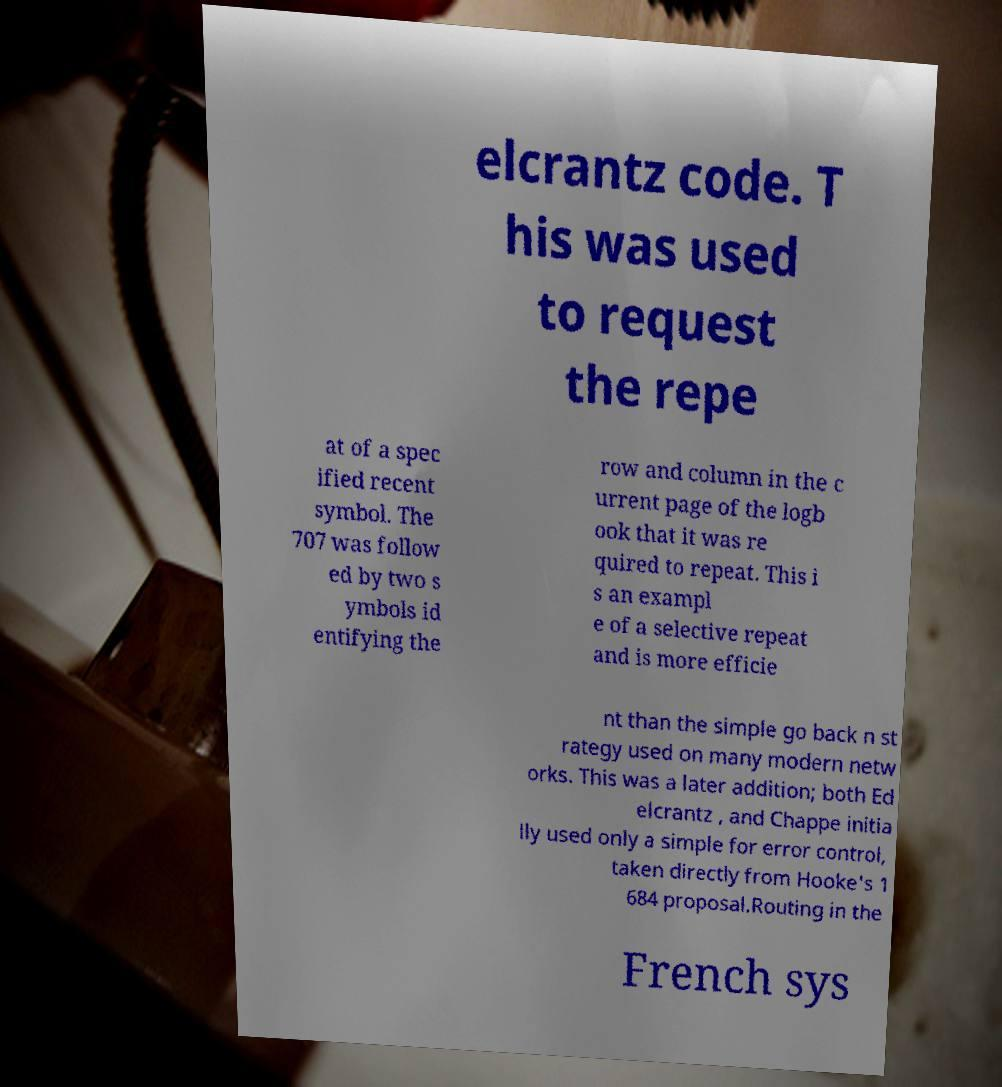Please identify and transcribe the text found in this image. elcrantz code. T his was used to request the repe at of a spec ified recent symbol. The 707 was follow ed by two s ymbols id entifying the row and column in the c urrent page of the logb ook that it was re quired to repeat. This i s an exampl e of a selective repeat and is more efficie nt than the simple go back n st rategy used on many modern netw orks. This was a later addition; both Ed elcrantz , and Chappe initia lly used only a simple for error control, taken directly from Hooke's 1 684 proposal.Routing in the French sys 